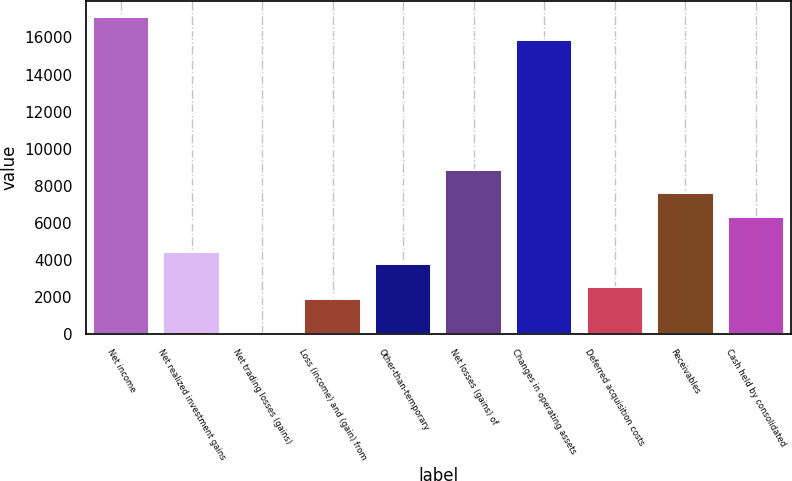Convert chart. <chart><loc_0><loc_0><loc_500><loc_500><bar_chart><fcel>Net income<fcel>Net realized investment gains<fcel>Net trading losses (gains)<fcel>Loss (income) and (gain) from<fcel>Other-than-temporary<fcel>Net losses (gains) of<fcel>Changes in operating assets<fcel>Deferred acquisition costs<fcel>Receivables<fcel>Cash held by consolidated<nl><fcel>17120<fcel>4440<fcel>2<fcel>1904<fcel>3806<fcel>8878<fcel>15852<fcel>2538<fcel>7610<fcel>6342<nl></chart> 